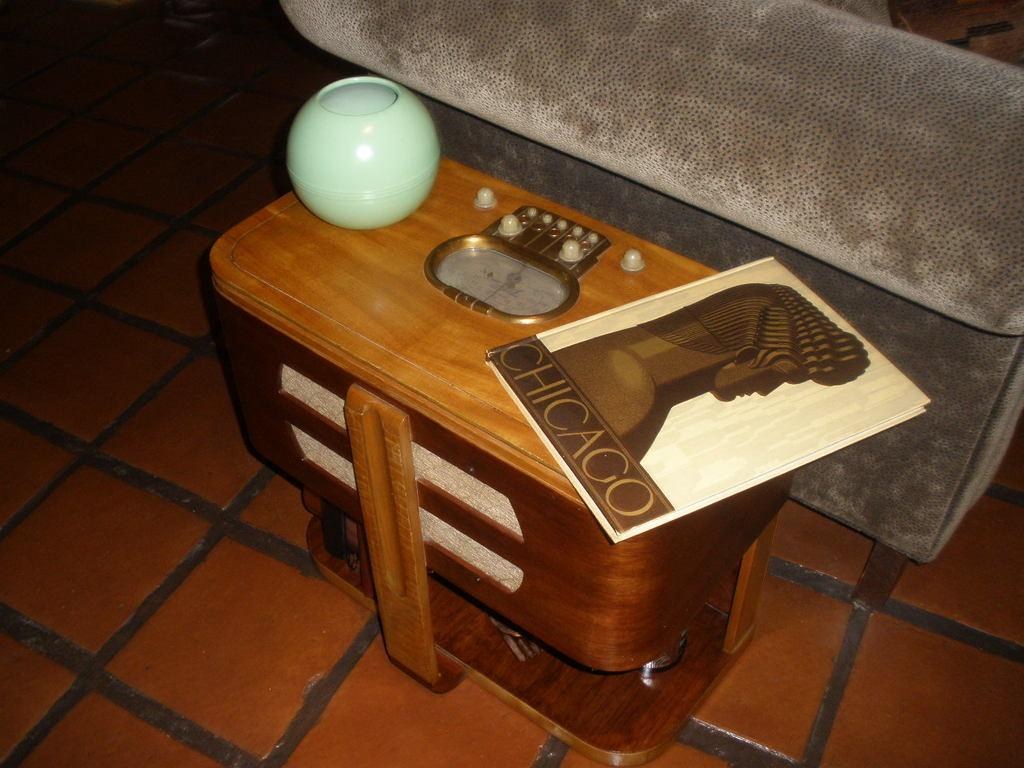What is the main object in the center of the image? There is a table in the center of the image. What can be found on the table? There are objects on the table, including a book. Can you describe the background of the image? The background of the image includes the floor. How many candles are on the cake in the image? There is no cake present in the image, so the number of candles cannot be determined. 